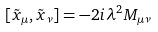Convert formula to latex. <formula><loc_0><loc_0><loc_500><loc_500>[ \tilde { x } _ { \mu } , \tilde { x } _ { \nu } ] = - 2 i \lambda ^ { 2 } M _ { \mu \nu }</formula> 